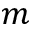Convert formula to latex. <formula><loc_0><loc_0><loc_500><loc_500>m</formula> 